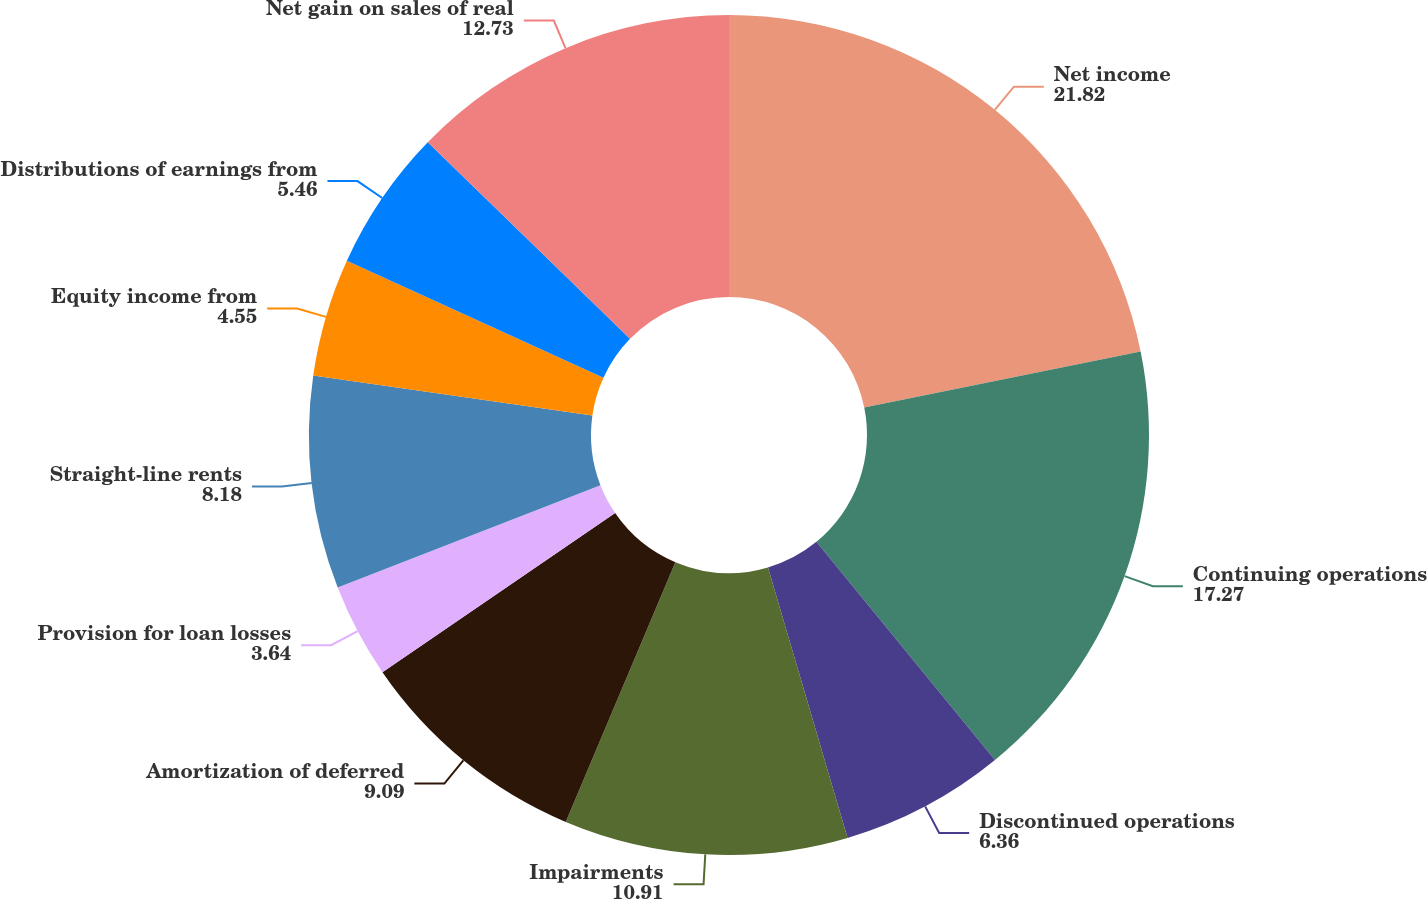Convert chart. <chart><loc_0><loc_0><loc_500><loc_500><pie_chart><fcel>Net income<fcel>Continuing operations<fcel>Discontinued operations<fcel>Impairments<fcel>Amortization of deferred<fcel>Provision for loan losses<fcel>Straight-line rents<fcel>Equity income from<fcel>Distributions of earnings from<fcel>Net gain on sales of real<nl><fcel>21.82%<fcel>17.27%<fcel>6.36%<fcel>10.91%<fcel>9.09%<fcel>3.64%<fcel>8.18%<fcel>4.55%<fcel>5.46%<fcel>12.73%<nl></chart> 